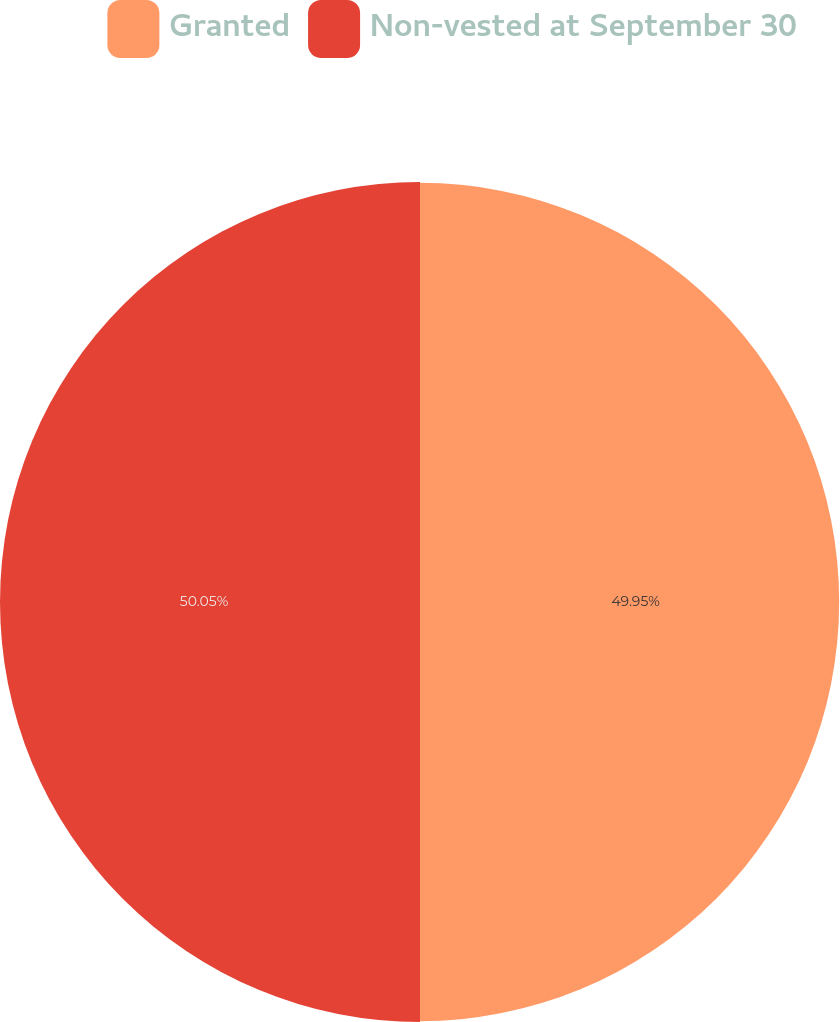Convert chart to OTSL. <chart><loc_0><loc_0><loc_500><loc_500><pie_chart><fcel>Granted<fcel>Non-vested at September 30<nl><fcel>49.95%<fcel>50.05%<nl></chart> 